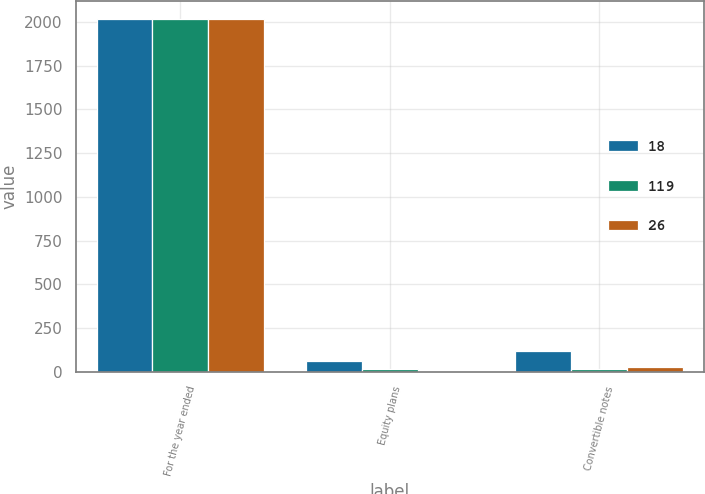<chart> <loc_0><loc_0><loc_500><loc_500><stacked_bar_chart><ecel><fcel>For the year ended<fcel>Equity plans<fcel>Convertible notes<nl><fcel>18<fcel>2016<fcel>60<fcel>119<nl><fcel>119<fcel>2015<fcel>18<fcel>18<nl><fcel>26<fcel>2014<fcel>7<fcel>26<nl></chart> 